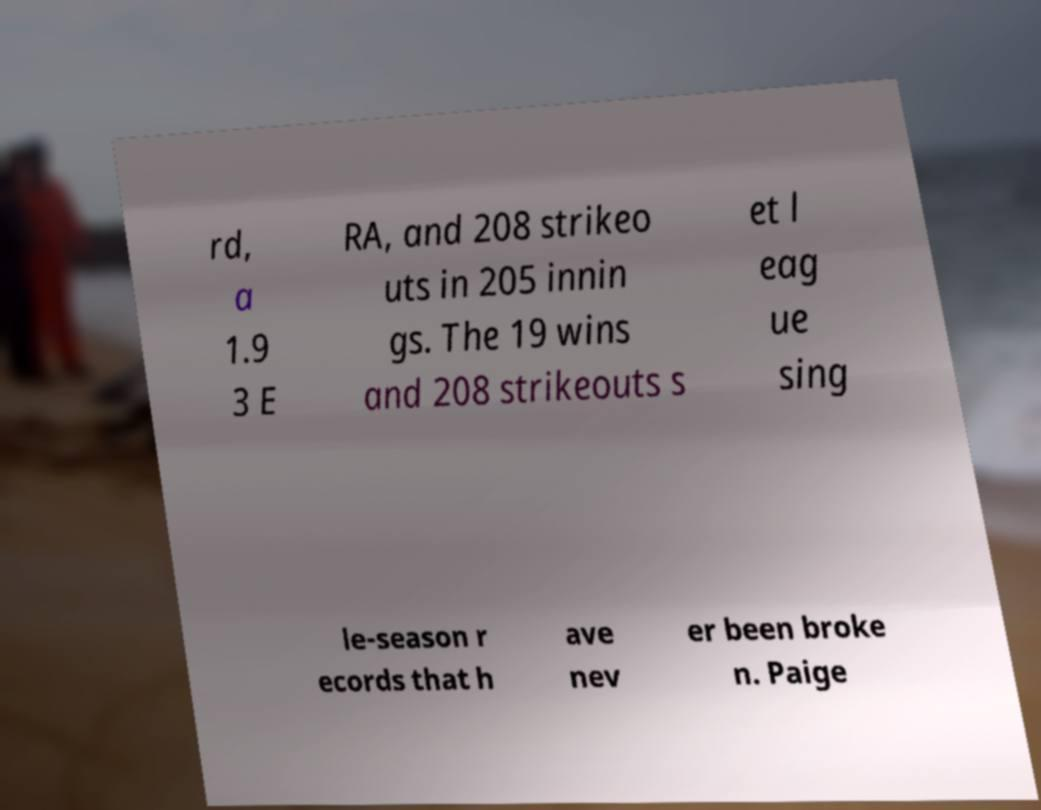There's text embedded in this image that I need extracted. Can you transcribe it verbatim? rd, a 1.9 3 E RA, and 208 strikeo uts in 205 innin gs. The 19 wins and 208 strikeouts s et l eag ue sing le-season r ecords that h ave nev er been broke n. Paige 